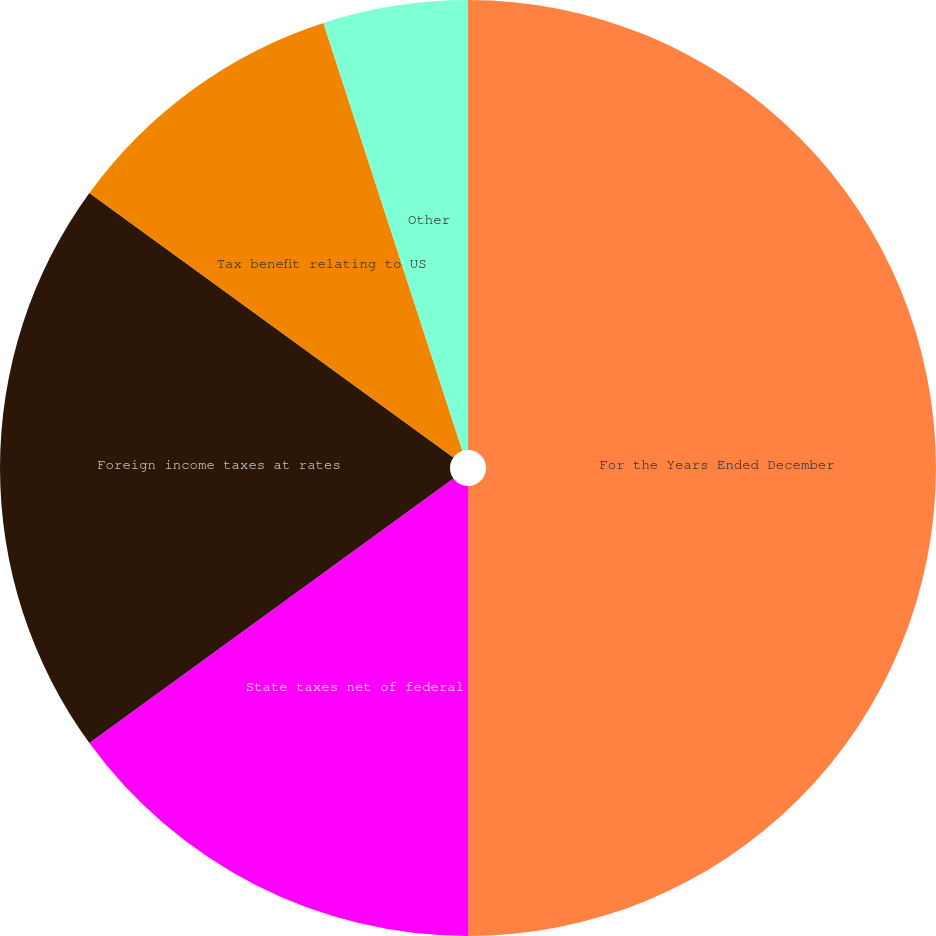<chart> <loc_0><loc_0><loc_500><loc_500><pie_chart><fcel>For the Years Ended December<fcel>State taxes net of federal<fcel>Foreign income taxes at rates<fcel>Tax benefit relating to US<fcel>R&D credit<fcel>Other<nl><fcel>50.0%<fcel>15.0%<fcel>20.0%<fcel>10.0%<fcel>0.0%<fcel>5.0%<nl></chart> 